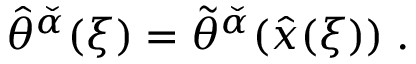Convert formula to latex. <formula><loc_0><loc_0><loc_500><loc_500>\hat { \theta } ^ { \check { \alpha } } ( \xi ) = \tilde { \theta } ^ { \check { \alpha } } ( \hat { x } ( \xi ) ) \, .</formula> 